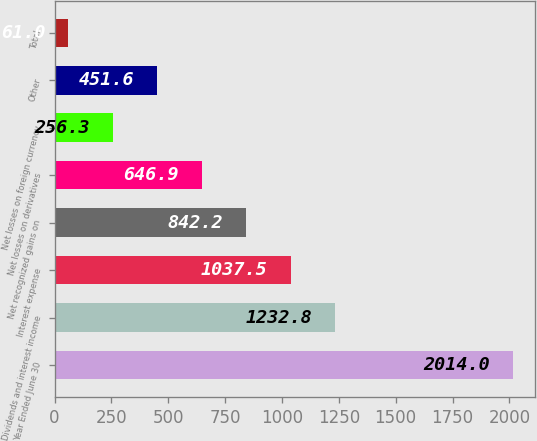Convert chart. <chart><loc_0><loc_0><loc_500><loc_500><bar_chart><fcel>Year Ended June 30<fcel>Dividends and interest income<fcel>Interest expense<fcel>Net recognized gains on<fcel>Net losses on derivatives<fcel>Net losses on foreign currency<fcel>Other<fcel>Total<nl><fcel>2014<fcel>1232.8<fcel>1037.5<fcel>842.2<fcel>646.9<fcel>256.3<fcel>451.6<fcel>61<nl></chart> 